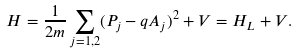Convert formula to latex. <formula><loc_0><loc_0><loc_500><loc_500>H = \frac { 1 } { 2 m } \sum _ { j = 1 , 2 } ( P _ { j } - q A _ { j } ) ^ { 2 } + V = H _ { L } + V .</formula> 